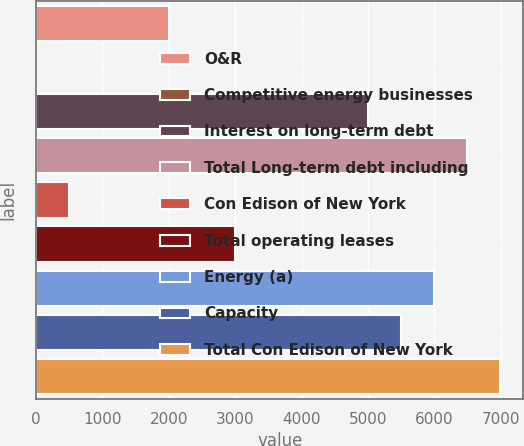<chart> <loc_0><loc_0><loc_500><loc_500><bar_chart><fcel>O&R<fcel>Competitive energy businesses<fcel>Interest on long-term debt<fcel>Total Long-term debt including<fcel>Con Edison of New York<fcel>Total operating leases<fcel>Energy (a)<fcel>Capacity<fcel>Total Con Edison of New York<nl><fcel>1999.4<fcel>3<fcel>4994<fcel>6491.3<fcel>502.1<fcel>2997.6<fcel>5992.2<fcel>5493.1<fcel>6990.4<nl></chart> 